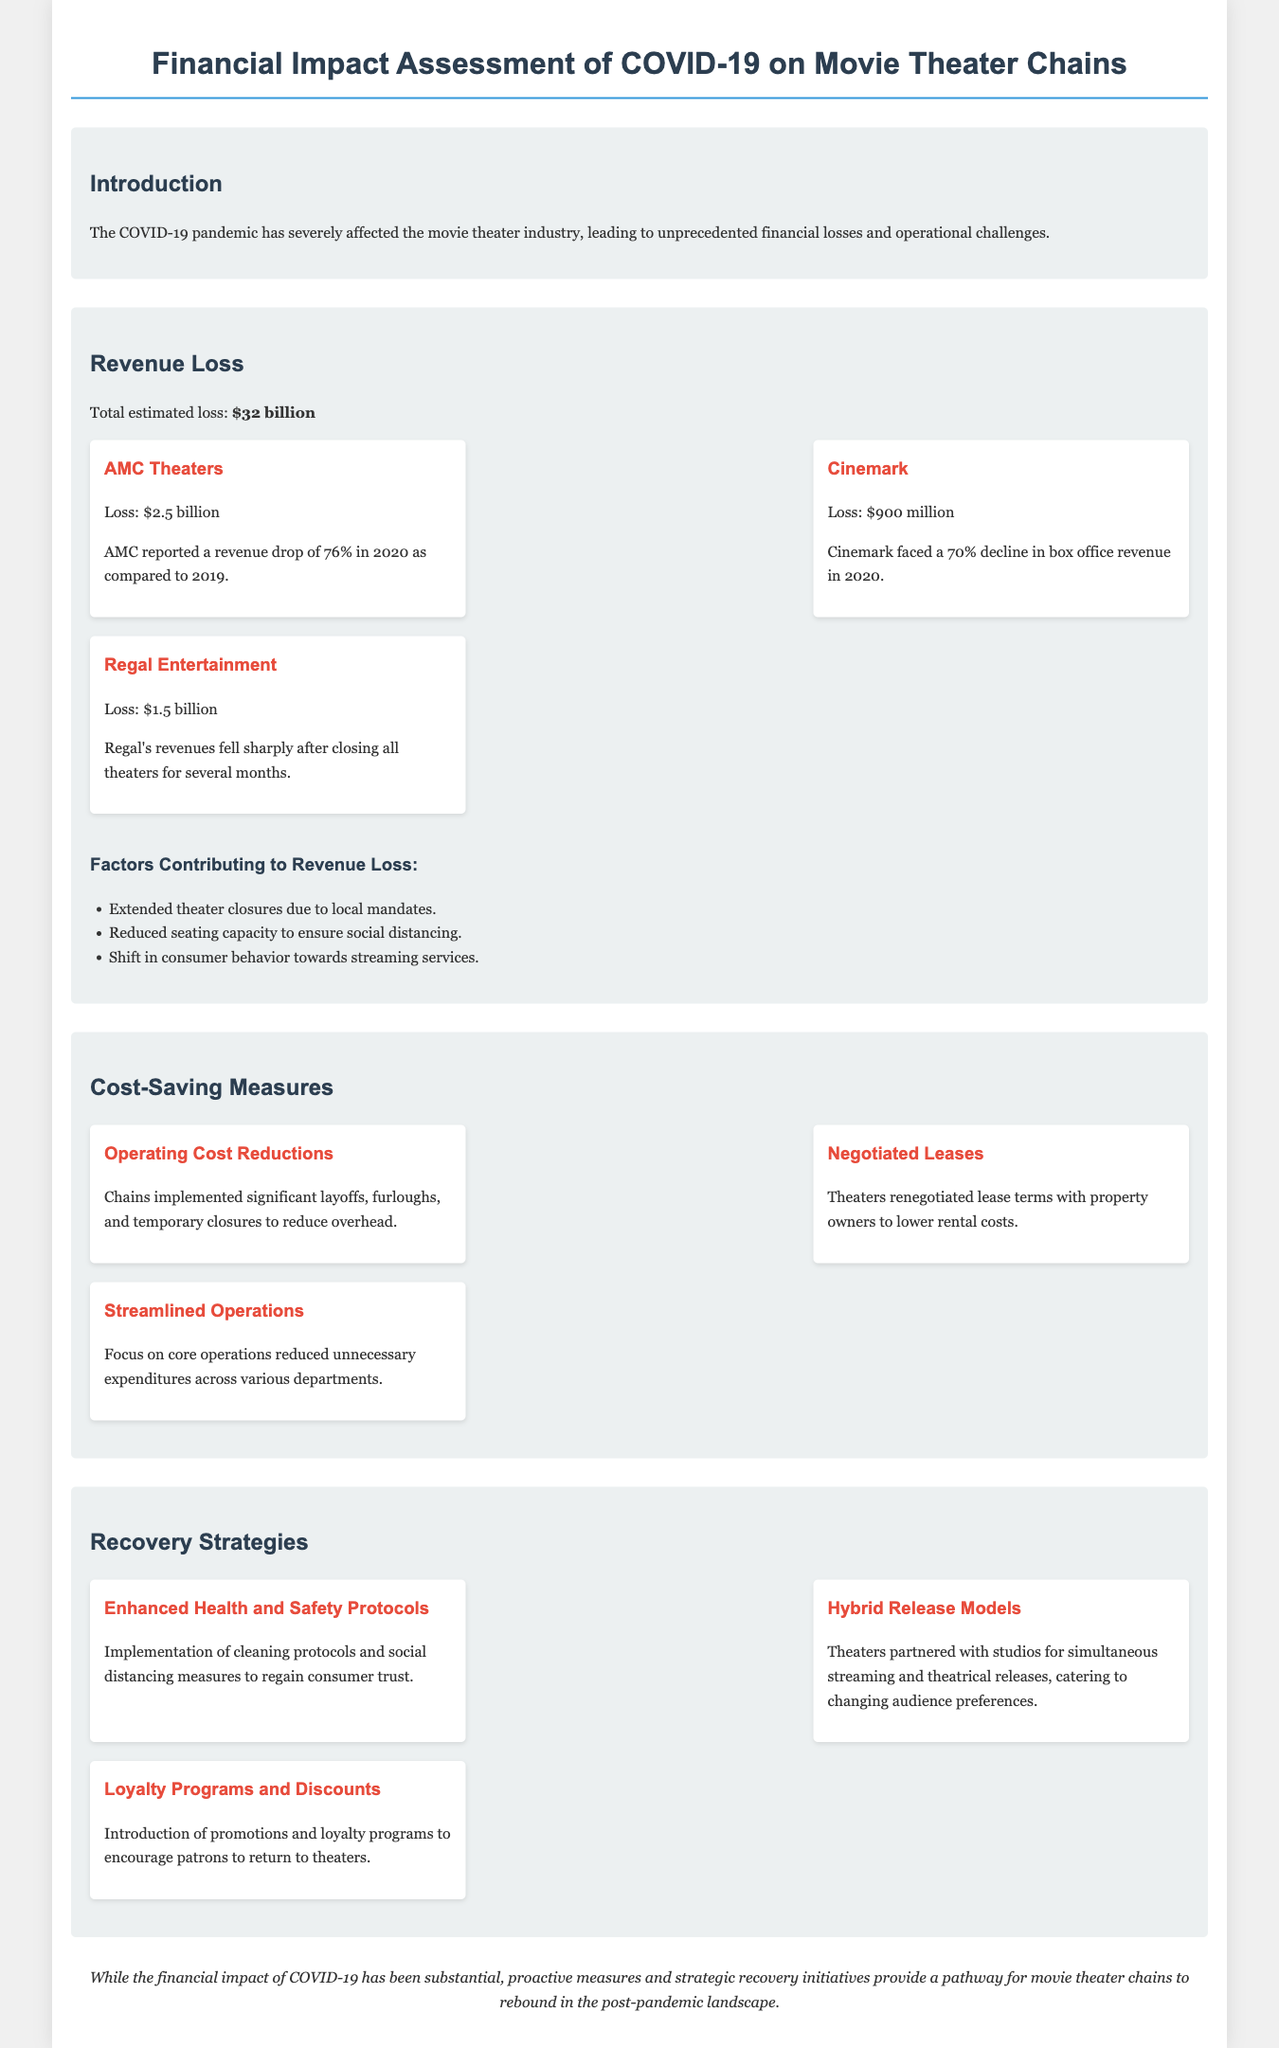What is the total estimated revenue loss? The total estimated revenue loss is stated in the document as $32 billion.
Answer: $32 billion What was AMC Theaters' revenue loss? AMC Theaters' revenue loss is specifically mentioned as $2.5 billion in the section about revenue loss.
Answer: $2.5 billion What percentage revenue drop did AMC report in 2020? AMC reported a revenue drop of 76% in 2020 as compared to 2019, which is explicitly noted in the document.
Answer: 76% What cost-saving measure involves renegotiating lease terms? The cost-saving measure that involves renegotiating lease terms is "Negotiated Leases," mentioned in the cost-saving measures section.
Answer: Negotiated Leases Which recovery strategy aims to regain consumer trust? The recovery strategy that aims to regain consumer trust is "Enhanced Health and Safety Protocols," detailed in the recovery strategies section.
Answer: Enhanced Health and Safety Protocols What contributed to the 70% decline in box office revenue for Cinemark? The document states the decline was due to circumstances including the pandemic's impact on the industry.
Answer: 70% What approach did theaters take for simultaneous releases? The approach taken by theaters for simultaneous releases is referred to as "Hybrid Release Models" in the recovery strategies section.
Answer: Hybrid Release Models What is one major factor behind revenue loss? One major factor behind revenue loss is the "Extended theater closures due to local mandates," as indicated in the document.
Answer: Extended theater closures What is the emphasis of the conclusion in the report? The conclusion emphasizes that proactive measures and strategic recovery initiatives provide a pathway for movie theater chains to rebound in the post-pandemic landscape.
Answer: Rebound in the post-pandemic landscape 